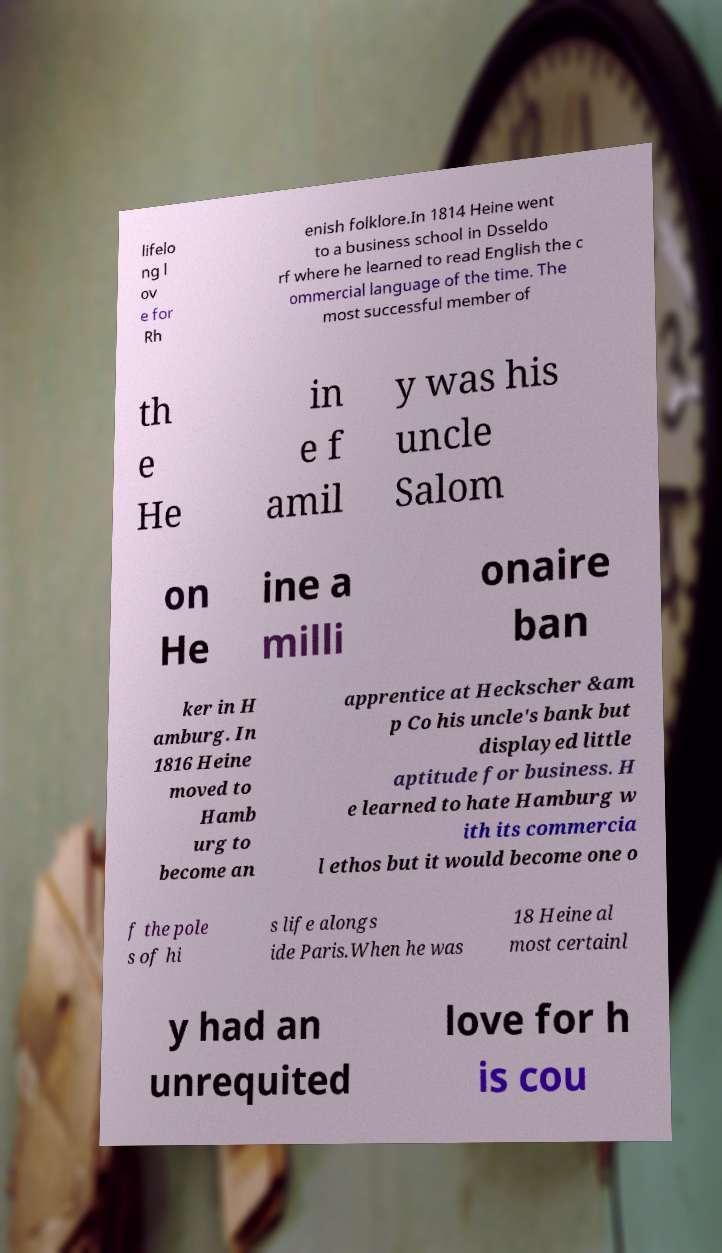Can you read and provide the text displayed in the image?This photo seems to have some interesting text. Can you extract and type it out for me? lifelo ng l ov e for Rh enish folklore.In 1814 Heine went to a business school in Dsseldo rf where he learned to read English the c ommercial language of the time. The most successful member of th e He in e f amil y was his uncle Salom on He ine a milli onaire ban ker in H amburg. In 1816 Heine moved to Hamb urg to become an apprentice at Heckscher &am p Co his uncle's bank but displayed little aptitude for business. H e learned to hate Hamburg w ith its commercia l ethos but it would become one o f the pole s of hi s life alongs ide Paris.When he was 18 Heine al most certainl y had an unrequited love for h is cou 